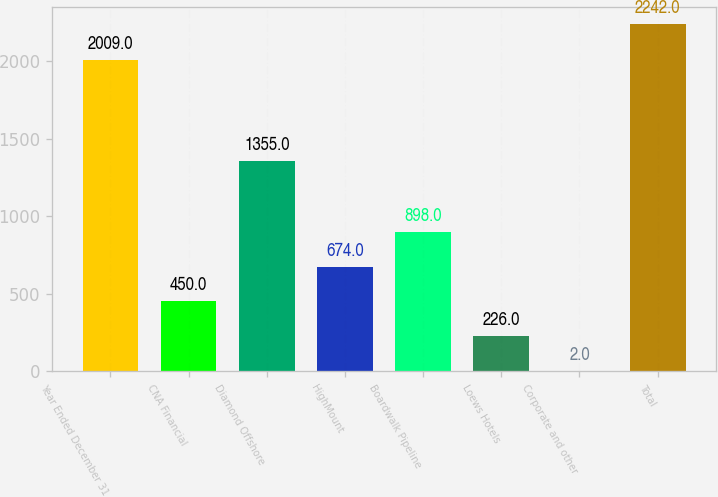Convert chart to OTSL. <chart><loc_0><loc_0><loc_500><loc_500><bar_chart><fcel>Year Ended December 31<fcel>CNA Financial<fcel>Diamond Offshore<fcel>HighMount<fcel>Boardwalk Pipeline<fcel>Loews Hotels<fcel>Corporate and other<fcel>Total<nl><fcel>2009<fcel>450<fcel>1355<fcel>674<fcel>898<fcel>226<fcel>2<fcel>2242<nl></chart> 